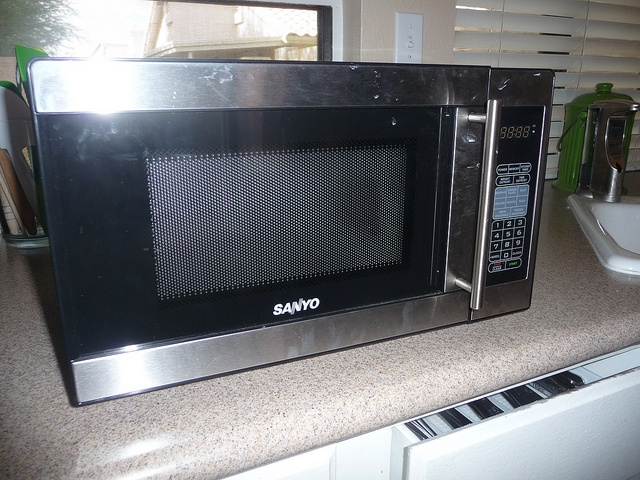Describe the objects in this image and their specific colors. I can see microwave in gray, black, darkgray, and white tones, sink in gray, darkgray, and lightgray tones, and knife in gray and black tones in this image. 